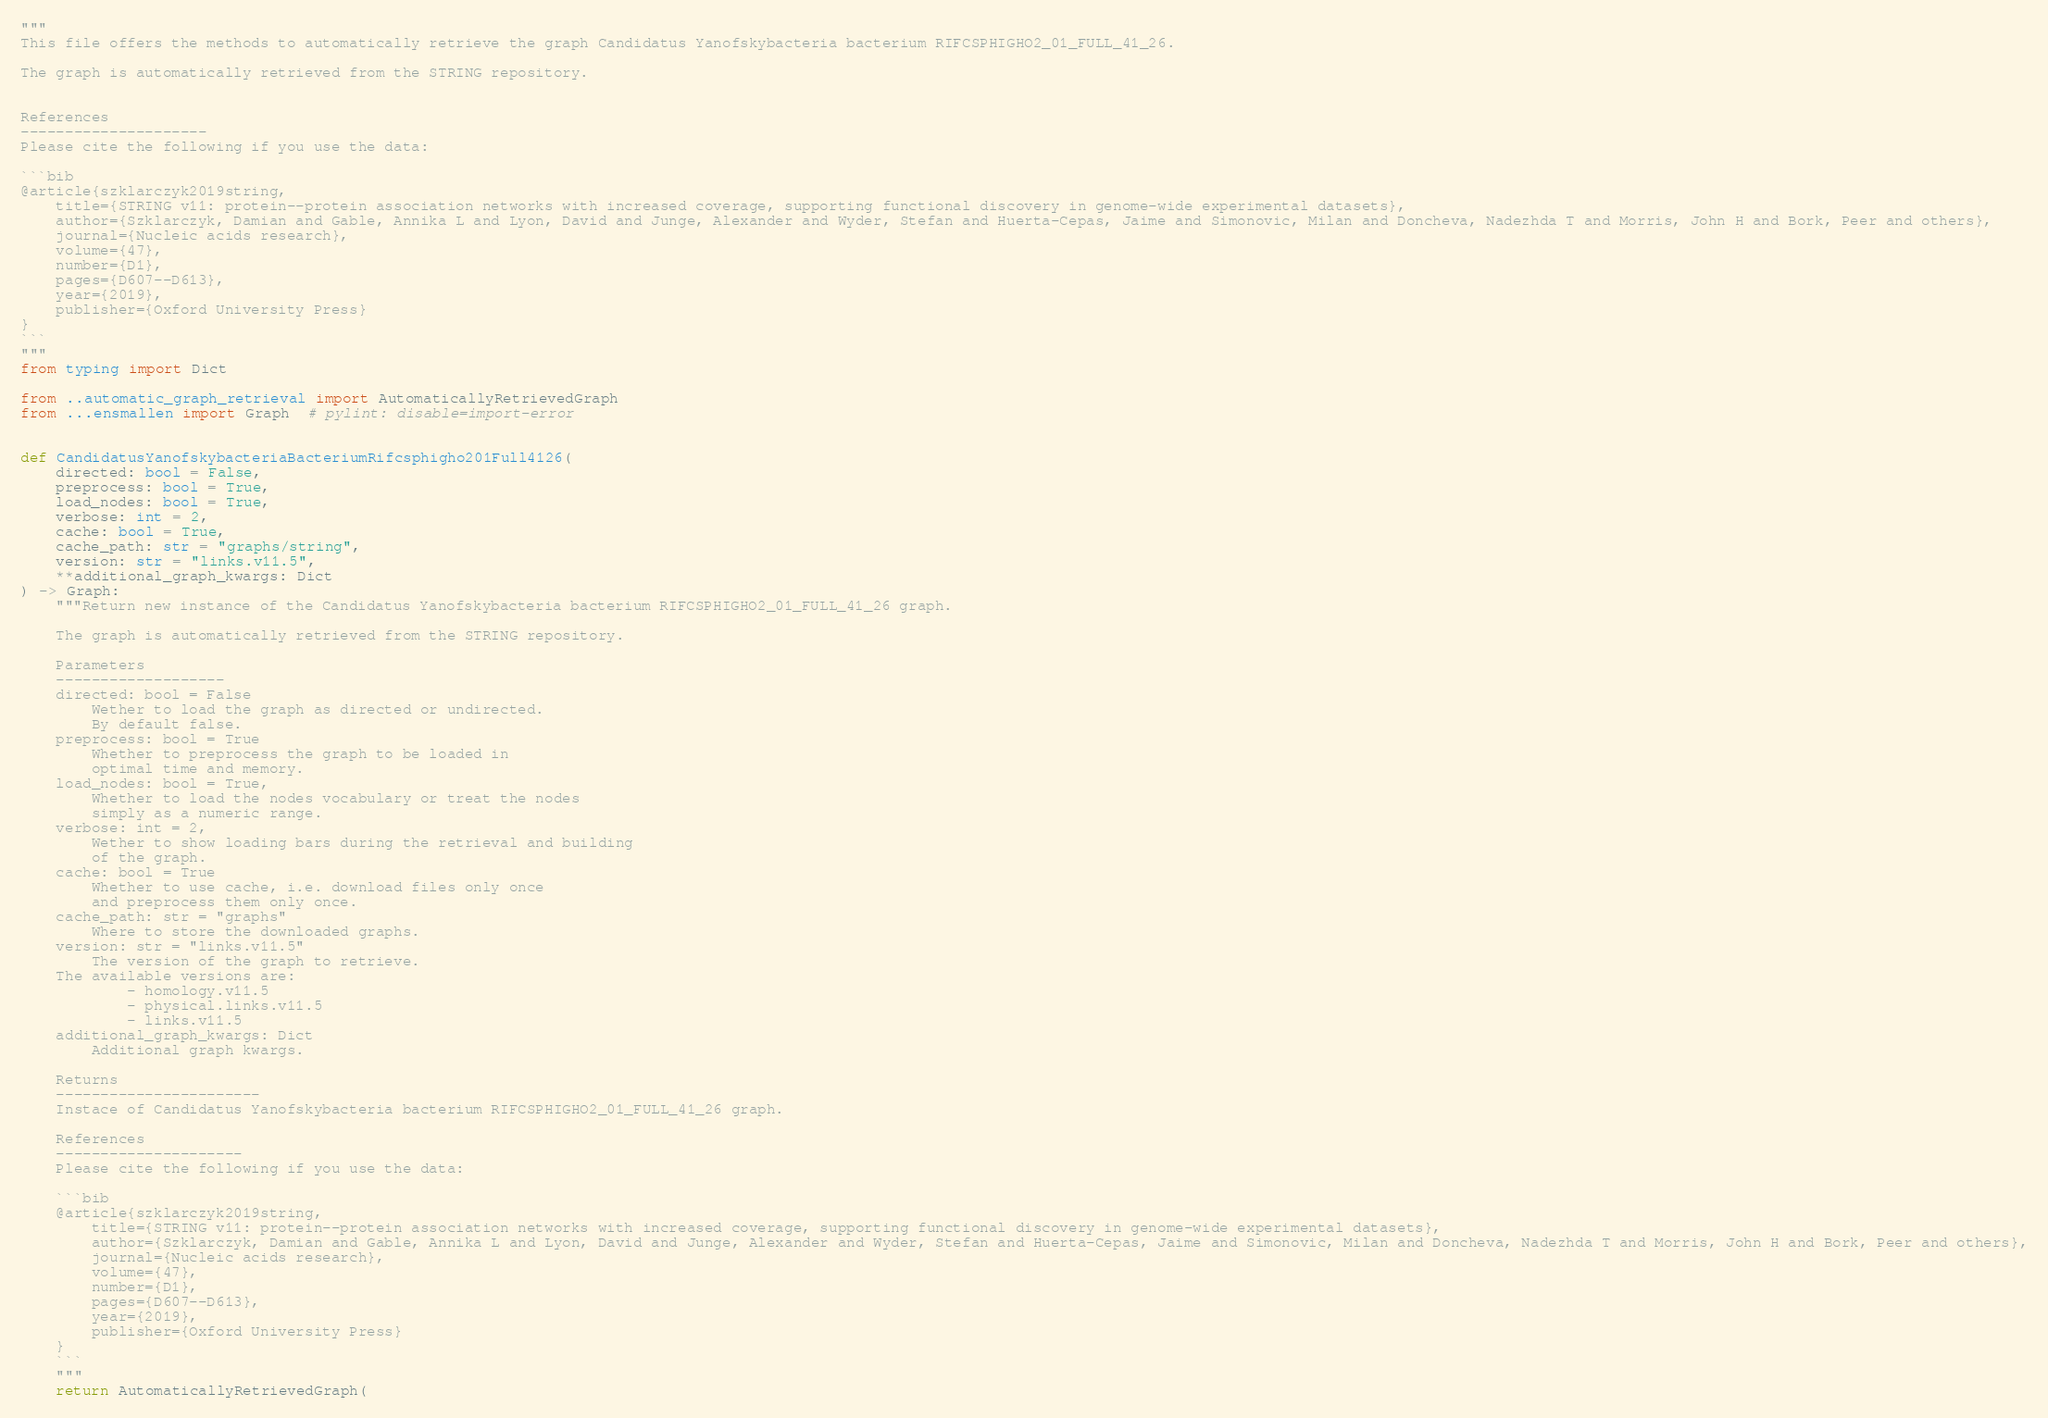<code> <loc_0><loc_0><loc_500><loc_500><_Python_>"""
This file offers the methods to automatically retrieve the graph Candidatus Yanofskybacteria bacterium RIFCSPHIGHO2_01_FULL_41_26.

The graph is automatically retrieved from the STRING repository. 


References
---------------------
Please cite the following if you use the data:

```bib
@article{szklarczyk2019string,
    title={STRING v11: protein--protein association networks with increased coverage, supporting functional discovery in genome-wide experimental datasets},
    author={Szklarczyk, Damian and Gable, Annika L and Lyon, David and Junge, Alexander and Wyder, Stefan and Huerta-Cepas, Jaime and Simonovic, Milan and Doncheva, Nadezhda T and Morris, John H and Bork, Peer and others},
    journal={Nucleic acids research},
    volume={47},
    number={D1},
    pages={D607--D613},
    year={2019},
    publisher={Oxford University Press}
}
```
"""
from typing import Dict

from ..automatic_graph_retrieval import AutomaticallyRetrievedGraph
from ...ensmallen import Graph  # pylint: disable=import-error


def CandidatusYanofskybacteriaBacteriumRifcsphigho201Full4126(
    directed: bool = False,
    preprocess: bool = True,
    load_nodes: bool = True,
    verbose: int = 2,
    cache: bool = True,
    cache_path: str = "graphs/string",
    version: str = "links.v11.5",
    **additional_graph_kwargs: Dict
) -> Graph:
    """Return new instance of the Candidatus Yanofskybacteria bacterium RIFCSPHIGHO2_01_FULL_41_26 graph.

    The graph is automatically retrieved from the STRING repository.	

    Parameters
    -------------------
    directed: bool = False
        Wether to load the graph as directed or undirected.
        By default false.
    preprocess: bool = True
        Whether to preprocess the graph to be loaded in 
        optimal time and memory.
    load_nodes: bool = True,
        Whether to load the nodes vocabulary or treat the nodes
        simply as a numeric range.
    verbose: int = 2,
        Wether to show loading bars during the retrieval and building
        of the graph.
    cache: bool = True
        Whether to use cache, i.e. download files only once
        and preprocess them only once.
    cache_path: str = "graphs"
        Where to store the downloaded graphs.
    version: str = "links.v11.5"
        The version of the graph to retrieve.		
	The available versions are:
			- homology.v11.5
			- physical.links.v11.5
			- links.v11.5
    additional_graph_kwargs: Dict
        Additional graph kwargs.

    Returns
    -----------------------
    Instace of Candidatus Yanofskybacteria bacterium RIFCSPHIGHO2_01_FULL_41_26 graph.

	References
	---------------------
	Please cite the following if you use the data:
	
	```bib
	@article{szklarczyk2019string,
	    title={STRING v11: protein--protein association networks with increased coverage, supporting functional discovery in genome-wide experimental datasets},
	    author={Szklarczyk, Damian and Gable, Annika L and Lyon, David and Junge, Alexander and Wyder, Stefan and Huerta-Cepas, Jaime and Simonovic, Milan and Doncheva, Nadezhda T and Morris, John H and Bork, Peer and others},
	    journal={Nucleic acids research},
	    volume={47},
	    number={D1},
	    pages={D607--D613},
	    year={2019},
	    publisher={Oxford University Press}
	}
	```
    """
    return AutomaticallyRetrievedGraph(</code> 